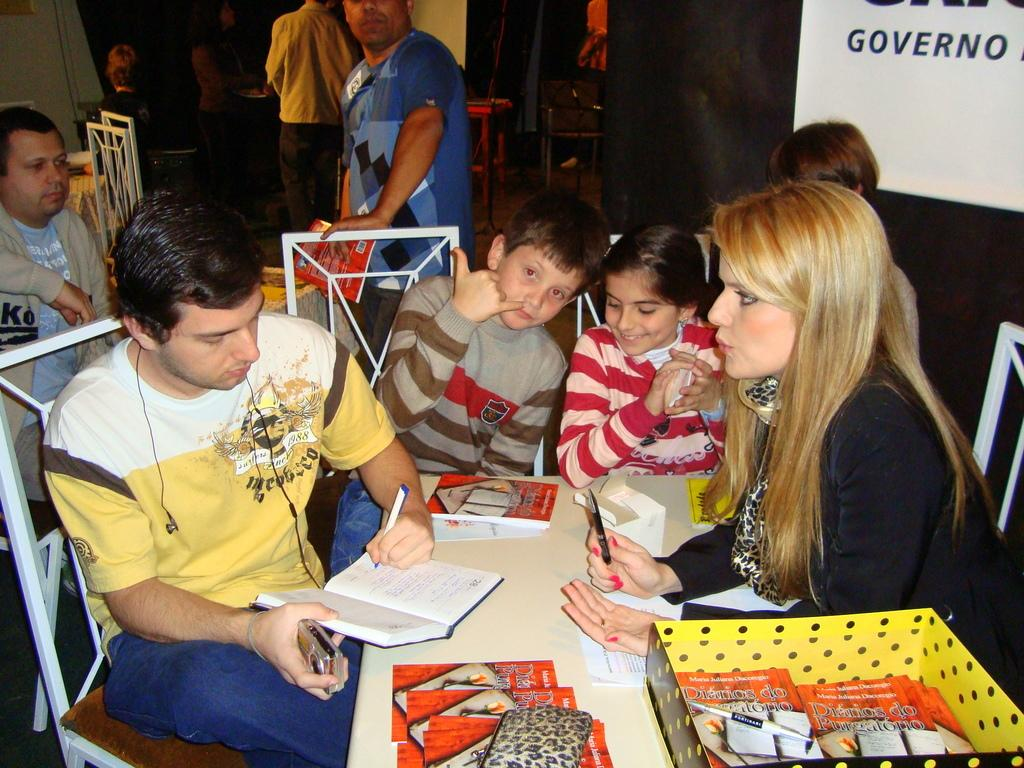<image>
Provide a brief description of the given image. Some children and adults are sitting at a table where pamphlets titled Diarios do Purgatorio are sitting in a box. 